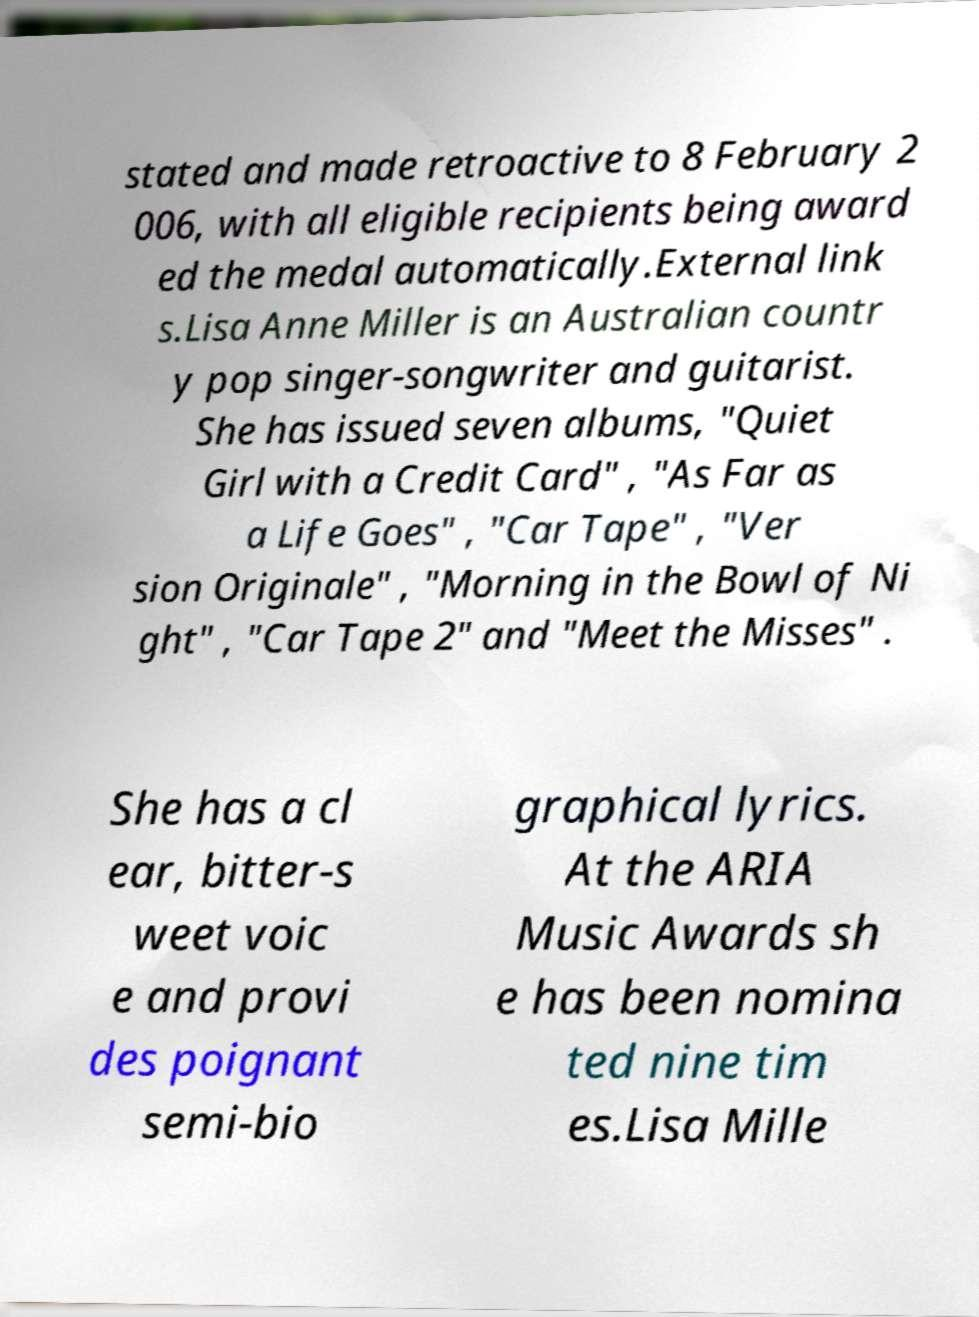Could you assist in decoding the text presented in this image and type it out clearly? stated and made retroactive to 8 February 2 006, with all eligible recipients being award ed the medal automatically.External link s.Lisa Anne Miller is an Australian countr y pop singer-songwriter and guitarist. She has issued seven albums, "Quiet Girl with a Credit Card" , "As Far as a Life Goes" , "Car Tape" , "Ver sion Originale" , "Morning in the Bowl of Ni ght" , "Car Tape 2" and "Meet the Misses" . She has a cl ear, bitter-s weet voic e and provi des poignant semi-bio graphical lyrics. At the ARIA Music Awards sh e has been nomina ted nine tim es.Lisa Mille 